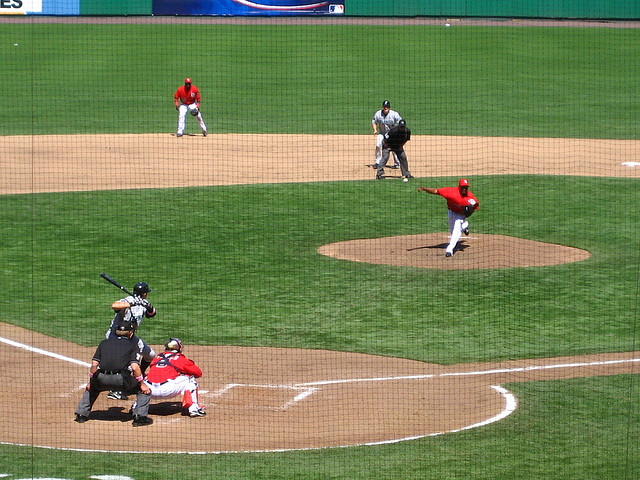How many people are there? 2 